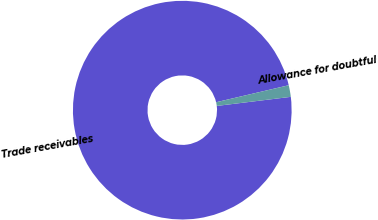Convert chart to OTSL. <chart><loc_0><loc_0><loc_500><loc_500><pie_chart><fcel>Trade receivables<fcel>Allowance for doubtful<nl><fcel>98.28%<fcel>1.72%<nl></chart> 